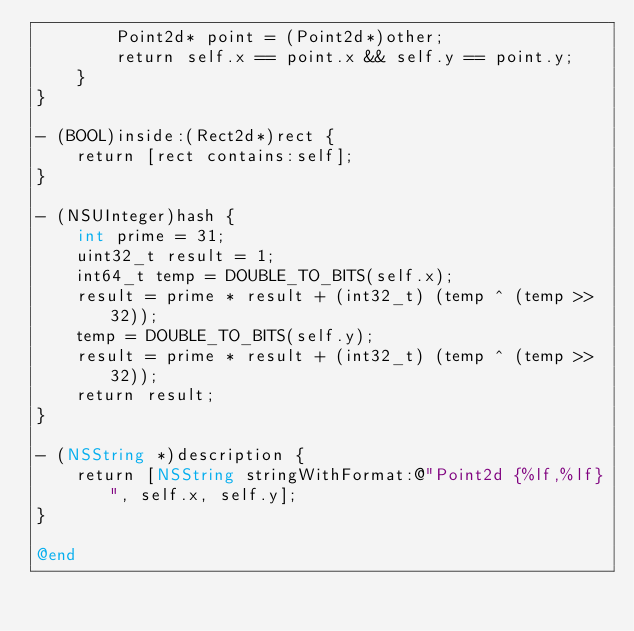<code> <loc_0><loc_0><loc_500><loc_500><_ObjectiveC_>        Point2d* point = (Point2d*)other;
        return self.x == point.x && self.y == point.y;
    }
}

- (BOOL)inside:(Rect2d*)rect {
    return [rect contains:self];
}

- (NSUInteger)hash {
    int prime = 31;
    uint32_t result = 1;
    int64_t temp = DOUBLE_TO_BITS(self.x);
    result = prime * result + (int32_t) (temp ^ (temp >> 32));
    temp = DOUBLE_TO_BITS(self.y);
    result = prime * result + (int32_t) (temp ^ (temp >> 32));
    return result;
}

- (NSString *)description {
    return [NSString stringWithFormat:@"Point2d {%lf,%lf}", self.x, self.y];
}

@end
</code> 